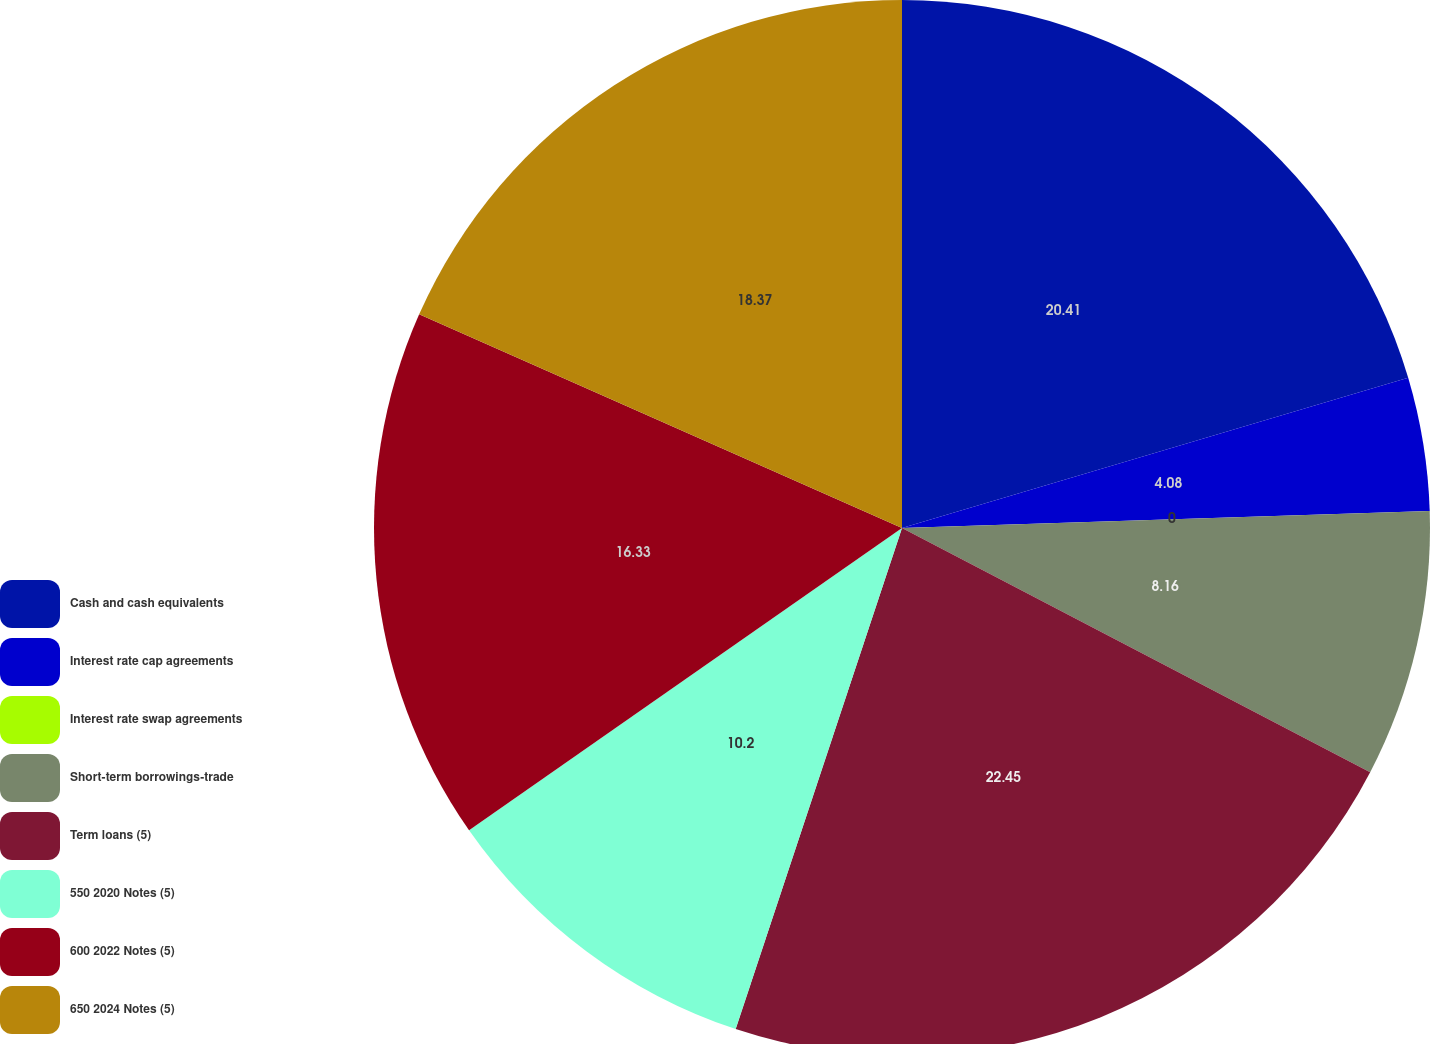<chart> <loc_0><loc_0><loc_500><loc_500><pie_chart><fcel>Cash and cash equivalents<fcel>Interest rate cap agreements<fcel>Interest rate swap agreements<fcel>Short-term borrowings-trade<fcel>Term loans (5)<fcel>550 2020 Notes (5)<fcel>600 2022 Notes (5)<fcel>650 2024 Notes (5)<nl><fcel>20.41%<fcel>4.08%<fcel>0.0%<fcel>8.16%<fcel>22.45%<fcel>10.2%<fcel>16.33%<fcel>18.37%<nl></chart> 